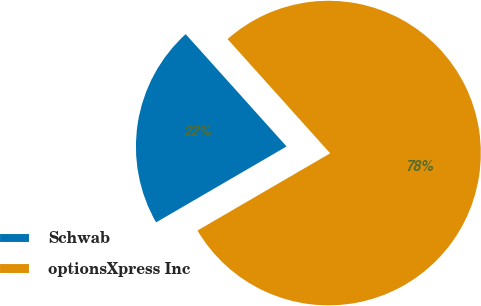Convert chart. <chart><loc_0><loc_0><loc_500><loc_500><pie_chart><fcel>Schwab<fcel>optionsXpress Inc<nl><fcel>21.74%<fcel>78.26%<nl></chart> 